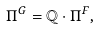<formula> <loc_0><loc_0><loc_500><loc_500>\Pi ^ { G } = \mathbb { Q } \cdot \Pi ^ { F } ,</formula> 